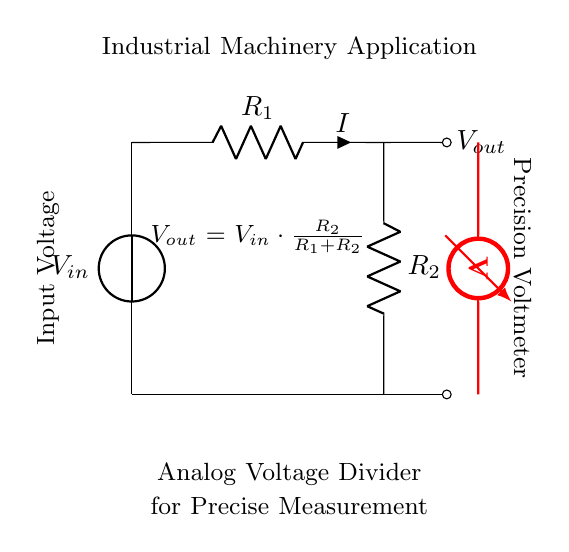What is the input voltage in the circuit? The input voltage is labeled as V_in in the circuit diagram.
Answer: V_in What do R_1 and R_2 represent in this circuit? R_1 and R_2 are resistors that form the voltage divider, reducing the input voltage to a lower output voltage.
Answer: Resistors What is the equation for the output voltage V_out? The output voltage is given by the formula V_out = V_in * (R_2 / (R_1 + R_2)), which describes how the voltage is divided between the two resistors.
Answer: V_out = V_in * (R_2 / (R_1 + R_2)) If R_1 is 1k ohm and R_2 is 2k ohm, what is the output voltage V_out if V_in is 9V? First, substitute R_1 and R_2 into the equation: V_out = 9 * (2 / (1 + 2)) = 9 * (2 / 3) = 6V.
Answer: 6V What is the role of the voltmeter in this circuit? The voltmeter is used to measure the output voltage V_out across R_2.
Answer: Measure V_out How does changing R_2 affect V_out? Increasing R_2 will increase V_out, while decreasing R_2 will lower V_out, according to the voltage divider equation.
Answer: It increases V_out 